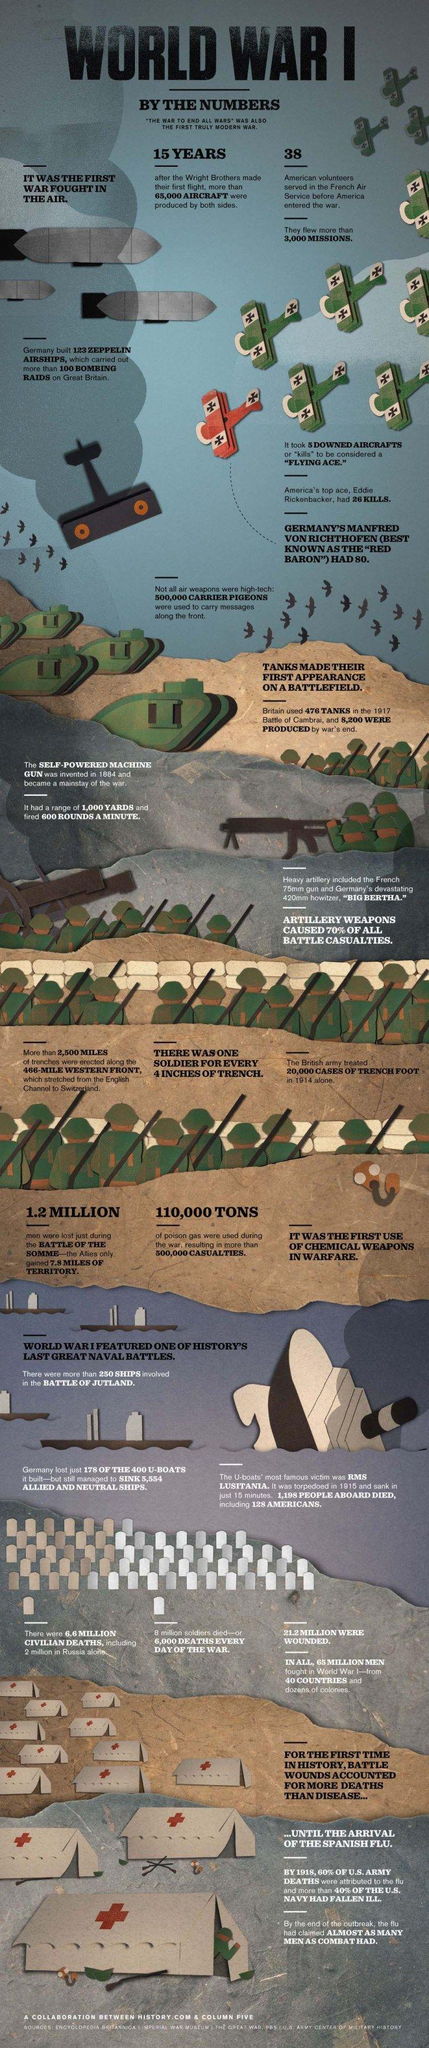Identify some key points in this picture. According to estimates, approximately 2 million civilians lost their lives in Russia during a specific historical event. Manfred Von Richthofen, also known as the "Red Baron," had a total of 80 kills during his career as a pilot in World War I. During World War I, carrier pigeons were used to carry messages along the front line. After the war, only 222 of the original 400 German U-boats remained. To be considered a flying ace, five kills were required. 